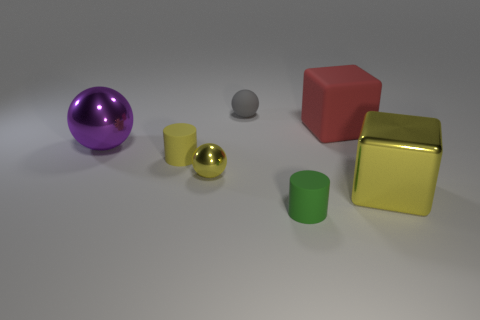What is the texture of the green object in comparison to the yellow metallic block? The green object has a matte finish, which diffuses light and gives it a flat appearance. In contrast, the yellow metallic block has a shiny, reflective surface that mirrors light, giving it a glossy and shimmering quality. 